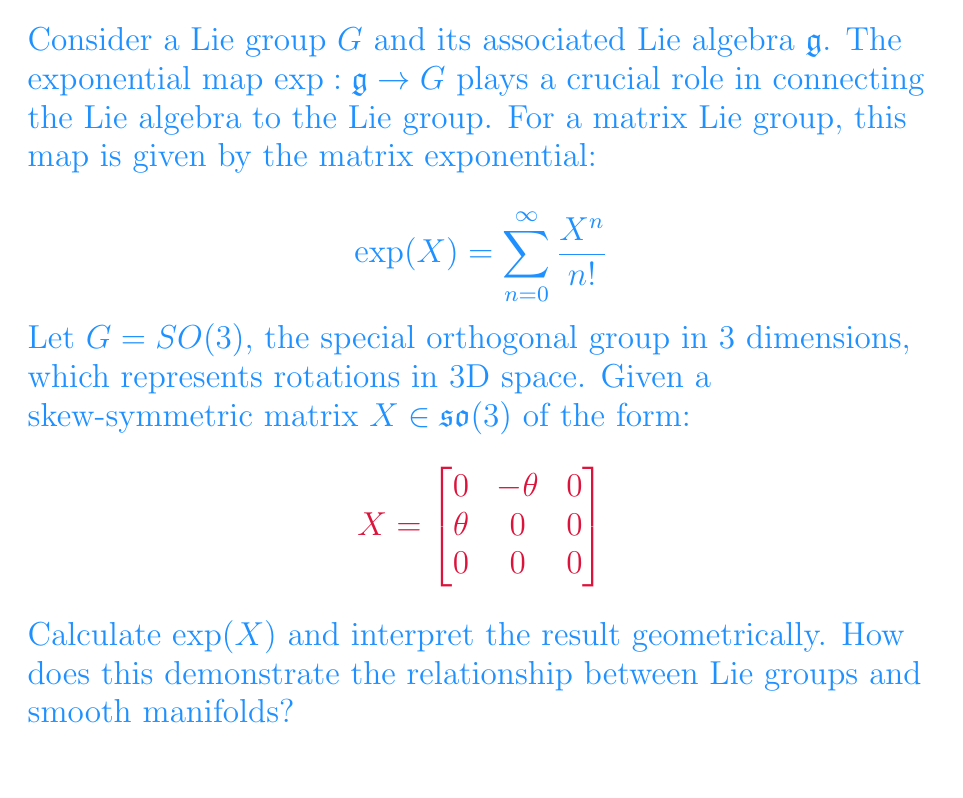Can you answer this question? To solve this problem, we'll follow these steps:

1) First, let's calculate the powers of X:
   $$X^2 = \begin{bmatrix}
   -\theta^2 & 0 & 0 \\
   0 & -\theta^2 & 0 \\
   0 & 0 & 0
   \end{bmatrix}$$
   
   $$X^3 = -\theta^2X$$
   
   We can see that the pattern repeats: even powers will be diagonal, and odd powers will be multiples of X.

2) Now, let's expand the exponential series:
   $$\exp(X) = I + X + \frac{X^2}{2!} + \frac{X^3}{3!} + \frac{X^4}{4!} + ...$$

3) Grouping the terms:
   $$\exp(X) = I + (X - \frac{\theta^2X}{3!} + \frac{\theta^4X}{5!} - ...) + (\frac{X^2}{2!} - \frac{\theta^2X^2}{4!} + ...)$$

4) Recognize the series expansions for sine and cosine:
   $$\exp(X) = I + \frac{\sin\theta}{\theta}X + (1-\cos\theta)\frac{X^2}{\theta^2}$$

5) Substituting the values:
   $$\exp(X) = \begin{bmatrix}
   \cos\theta & -\sin\theta & 0 \\
   \sin\theta & \cos\theta & 0 \\
   0 & 0 & 1
   \end{bmatrix}$$

6) Geometrically, this represents a rotation by angle $\theta$ around the z-axis.

This demonstrates the relationship between Lie groups and smooth manifolds in several ways:

a) The exponential map takes an element of the Lie algebra (a tangent space at the identity) and maps it to an element of the Lie group (a point on the manifold).

b) The result is a smooth path on the manifold $SO(3)$, parameterized by $\theta$. This shows how the Lie algebra generates one-parameter subgroups of the Lie group.

c) The manifold structure of $SO(3)$ is evident: it's a 3-dimensional smooth manifold where each point represents a 3D rotation.

d) The local structure of the Lie group near the identity is captured by the Lie algebra, demonstrating the power of the exponential map in connecting the infinitesimal (algebra) to the global (group) structure.
Answer: $\exp(X) = \begin{bmatrix}
\cos\theta & -\sin\theta & 0 \\
\sin\theta & \cos\theta & 0 \\
0 & 0 & 1
\end{bmatrix}$, representing a rotation by $\theta$ around the z-axis. 